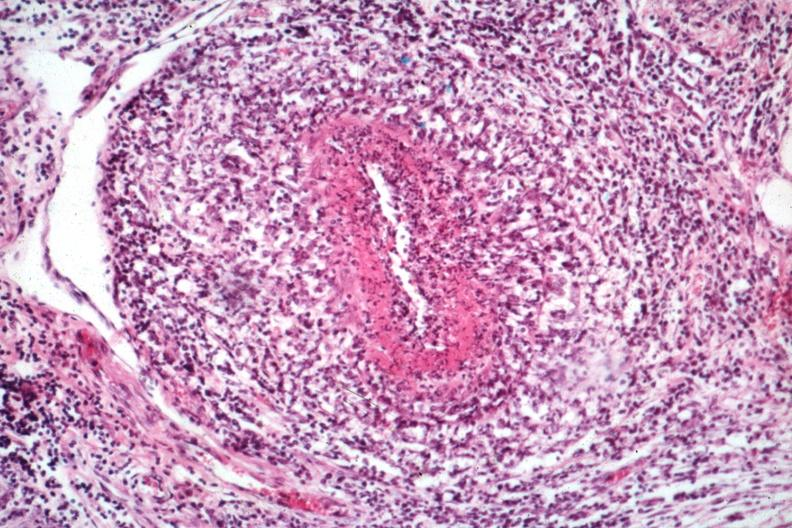what does this image show?
Answer the question using a single word or phrase. Classical polyarteritis nodosa type lesion 